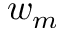Convert formula to latex. <formula><loc_0><loc_0><loc_500><loc_500>w _ { m }</formula> 